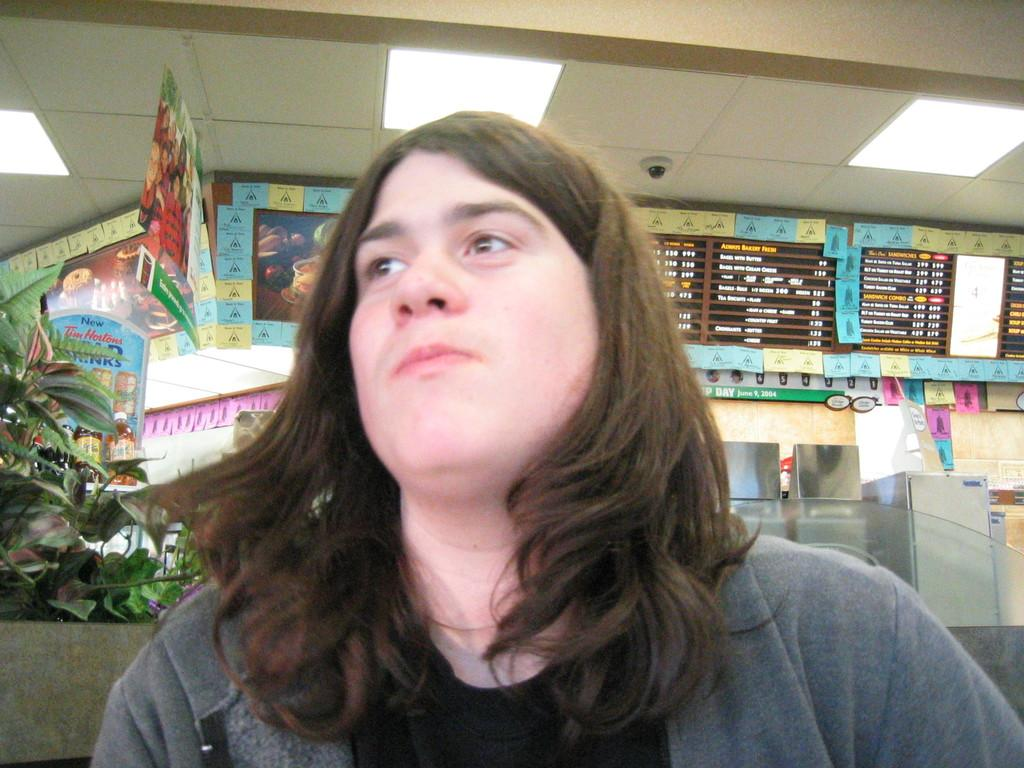What is the person in the image wearing? The person in the image is wearing clothes. What type of natural elements can be seen in the image? There are leaves visible in the image. What type of objects are present on the walls in the image? There are posters in the image. What can be read on the posters in the image? The posters have text on them. What type of artificial light sources are visible in the image? There are lights visible in the image. What type of honey can be seen dripping from the posters in the image? There is no honey present in the image; it only features a person, leaves, posters, and lights. 